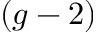<formula> <loc_0><loc_0><loc_500><loc_500>( g - 2 )</formula> 